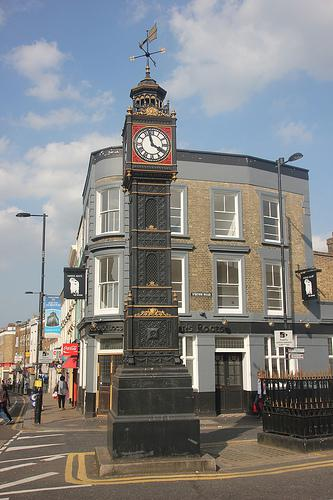Question: what is on top of the tower?
Choices:
A. Guns.
B. Cannons.
C. Rockets.
D. Arrows.
Answer with the letter. Answer: D Question: what is on the tower?
Choices:
A. People.
B. A bell.
C. A clock.
D. A flag.
Answer with the letter. Answer: C Question: how is the sky?
Choices:
A. Blue.
B. Cloudy.
C. Bright.
D. Clear.
Answer with the letter. Answer: C Question: how many clocks?
Choices:
A. Two.
B. Four.
C. One.
D. Five.
Answer with the letter. Answer: C Question: what color are the hands on the clock?
Choices:
A. Black.
B. Silver.
C. Blue.
D. Green.
Answer with the letter. Answer: A 